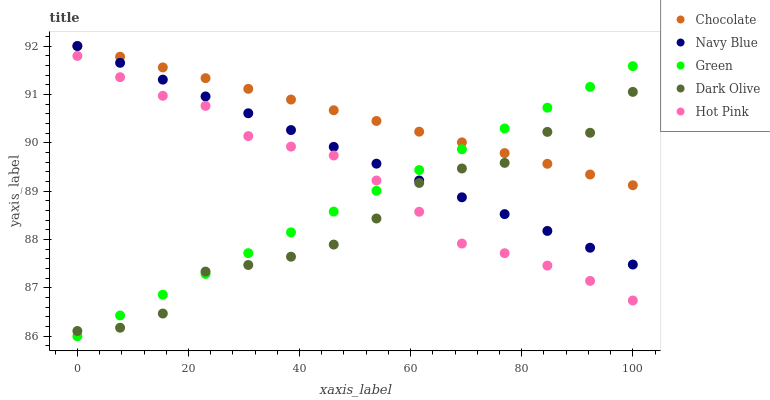Does Dark Olive have the minimum area under the curve?
Answer yes or no. Yes. Does Chocolate have the maximum area under the curve?
Answer yes or no. Yes. Does Hot Pink have the minimum area under the curve?
Answer yes or no. No. Does Hot Pink have the maximum area under the curve?
Answer yes or no. No. Is Navy Blue the smoothest?
Answer yes or no. Yes. Is Dark Olive the roughest?
Answer yes or no. Yes. Is Hot Pink the smoothest?
Answer yes or no. No. Is Hot Pink the roughest?
Answer yes or no. No. Does Green have the lowest value?
Answer yes or no. Yes. Does Hot Pink have the lowest value?
Answer yes or no. No. Does Chocolate have the highest value?
Answer yes or no. Yes. Does Hot Pink have the highest value?
Answer yes or no. No. Is Hot Pink less than Navy Blue?
Answer yes or no. Yes. Is Chocolate greater than Hot Pink?
Answer yes or no. Yes. Does Green intersect Dark Olive?
Answer yes or no. Yes. Is Green less than Dark Olive?
Answer yes or no. No. Is Green greater than Dark Olive?
Answer yes or no. No. Does Hot Pink intersect Navy Blue?
Answer yes or no. No. 